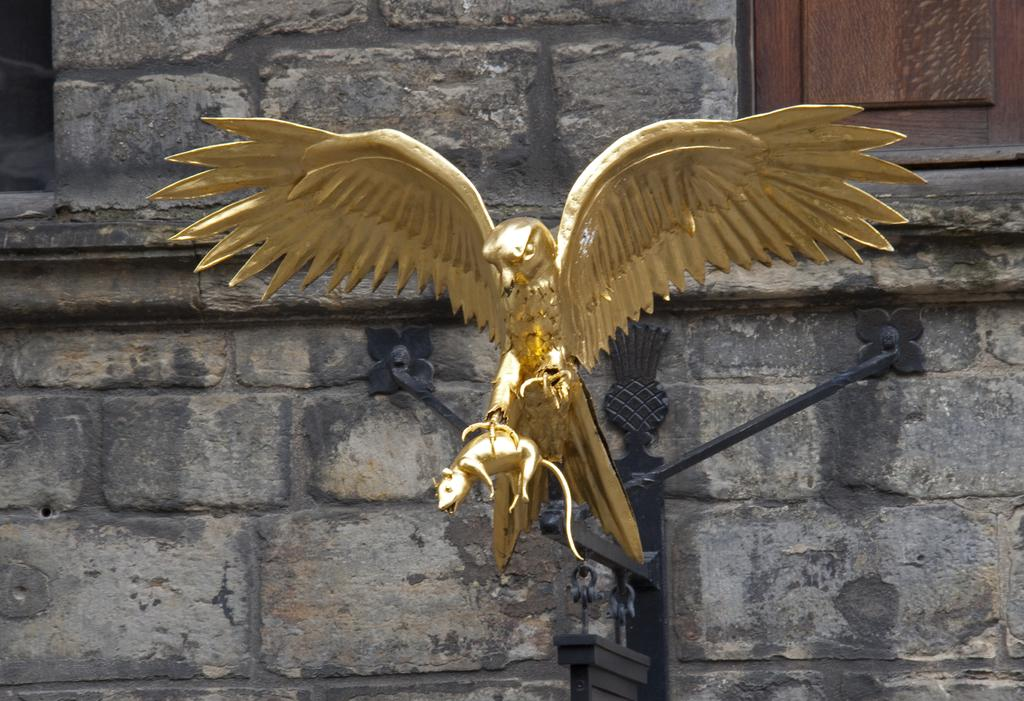What is the main subject of the image? There is a statue of a bird holding a mouse in the image. What can be seen in the background of the image? There is a wall in the background of the image. Is there any opening in the wall visible in the image? Yes, there is a window in the image. What type of pin is holding the bird's wing in place in the image? There is no pin holding the bird's wing in place in the image; it is a statue and not a real bird. 